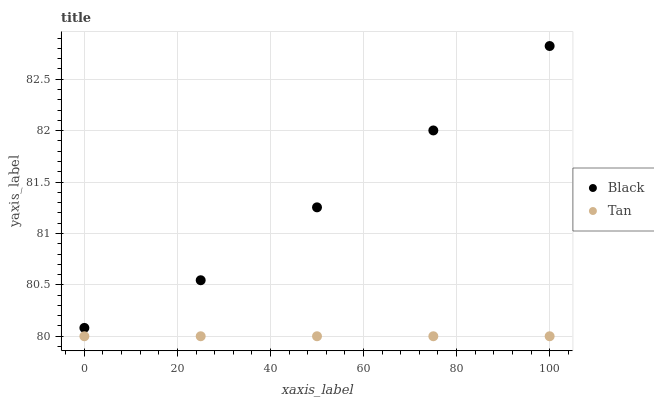Does Tan have the minimum area under the curve?
Answer yes or no. Yes. Does Black have the maximum area under the curve?
Answer yes or no. Yes. Does Black have the minimum area under the curve?
Answer yes or no. No. Is Tan the smoothest?
Answer yes or no. Yes. Is Black the roughest?
Answer yes or no. Yes. Is Black the smoothest?
Answer yes or no. No. Does Tan have the lowest value?
Answer yes or no. Yes. Does Black have the lowest value?
Answer yes or no. No. Does Black have the highest value?
Answer yes or no. Yes. Is Tan less than Black?
Answer yes or no. Yes. Is Black greater than Tan?
Answer yes or no. Yes. Does Tan intersect Black?
Answer yes or no. No. 